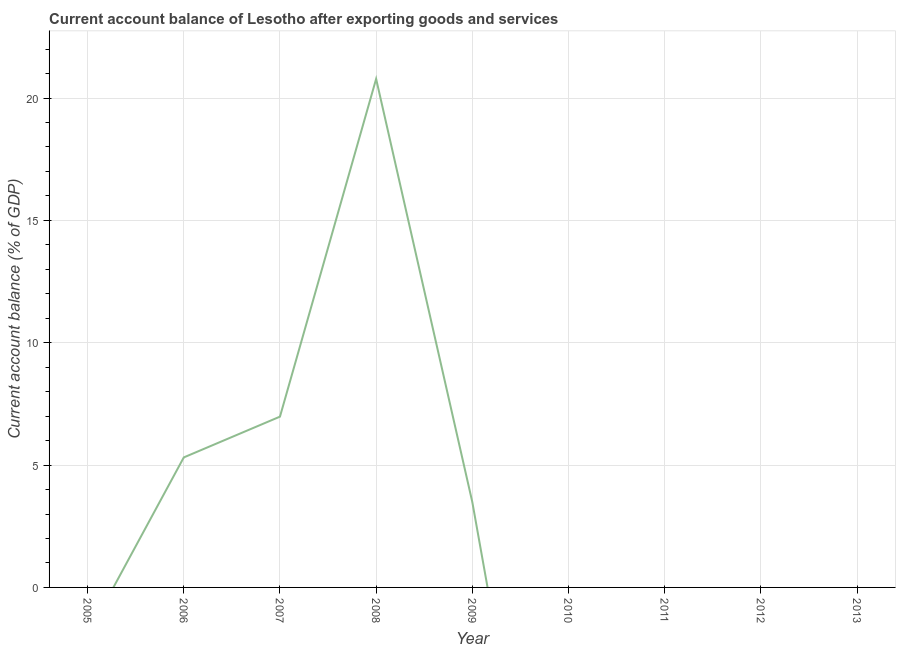What is the current account balance in 2009?
Offer a very short reply. 3.49. Across all years, what is the maximum current account balance?
Give a very brief answer. 20.78. In which year was the current account balance maximum?
Provide a succinct answer. 2008. What is the sum of the current account balance?
Ensure brevity in your answer.  36.56. What is the difference between the current account balance in 2006 and 2007?
Your answer should be compact. -1.67. What is the average current account balance per year?
Offer a very short reply. 4.06. What is the median current account balance?
Your answer should be compact. 0. In how many years, is the current account balance greater than 16 %?
Your response must be concise. 1. Is the difference between the current account balance in 2007 and 2009 greater than the difference between any two years?
Provide a short and direct response. No. What is the difference between the highest and the second highest current account balance?
Ensure brevity in your answer.  13.8. What is the difference between the highest and the lowest current account balance?
Provide a succinct answer. 20.78. In how many years, is the current account balance greater than the average current account balance taken over all years?
Offer a very short reply. 3. Does the current account balance monotonically increase over the years?
Offer a terse response. No. How many lines are there?
Keep it short and to the point. 1. What is the difference between two consecutive major ticks on the Y-axis?
Keep it short and to the point. 5. Are the values on the major ticks of Y-axis written in scientific E-notation?
Your answer should be very brief. No. What is the title of the graph?
Provide a succinct answer. Current account balance of Lesotho after exporting goods and services. What is the label or title of the X-axis?
Offer a very short reply. Year. What is the label or title of the Y-axis?
Offer a terse response. Current account balance (% of GDP). What is the Current account balance (% of GDP) of 2006?
Your response must be concise. 5.31. What is the Current account balance (% of GDP) of 2007?
Your response must be concise. 6.98. What is the Current account balance (% of GDP) in 2008?
Your response must be concise. 20.78. What is the Current account balance (% of GDP) of 2009?
Provide a succinct answer. 3.49. What is the Current account balance (% of GDP) of 2010?
Ensure brevity in your answer.  0. What is the Current account balance (% of GDP) of 2011?
Offer a terse response. 0. What is the Current account balance (% of GDP) in 2012?
Your answer should be very brief. 0. What is the Current account balance (% of GDP) of 2013?
Offer a very short reply. 0. What is the difference between the Current account balance (% of GDP) in 2006 and 2007?
Ensure brevity in your answer.  -1.67. What is the difference between the Current account balance (% of GDP) in 2006 and 2008?
Give a very brief answer. -15.47. What is the difference between the Current account balance (% of GDP) in 2006 and 2009?
Ensure brevity in your answer.  1.83. What is the difference between the Current account balance (% of GDP) in 2007 and 2008?
Make the answer very short. -13.8. What is the difference between the Current account balance (% of GDP) in 2007 and 2009?
Keep it short and to the point. 3.49. What is the difference between the Current account balance (% of GDP) in 2008 and 2009?
Give a very brief answer. 17.29. What is the ratio of the Current account balance (% of GDP) in 2006 to that in 2007?
Provide a succinct answer. 0.76. What is the ratio of the Current account balance (% of GDP) in 2006 to that in 2008?
Provide a succinct answer. 0.26. What is the ratio of the Current account balance (% of GDP) in 2006 to that in 2009?
Offer a very short reply. 1.52. What is the ratio of the Current account balance (% of GDP) in 2007 to that in 2008?
Your response must be concise. 0.34. What is the ratio of the Current account balance (% of GDP) in 2007 to that in 2009?
Give a very brief answer. 2. What is the ratio of the Current account balance (% of GDP) in 2008 to that in 2009?
Provide a short and direct response. 5.96. 